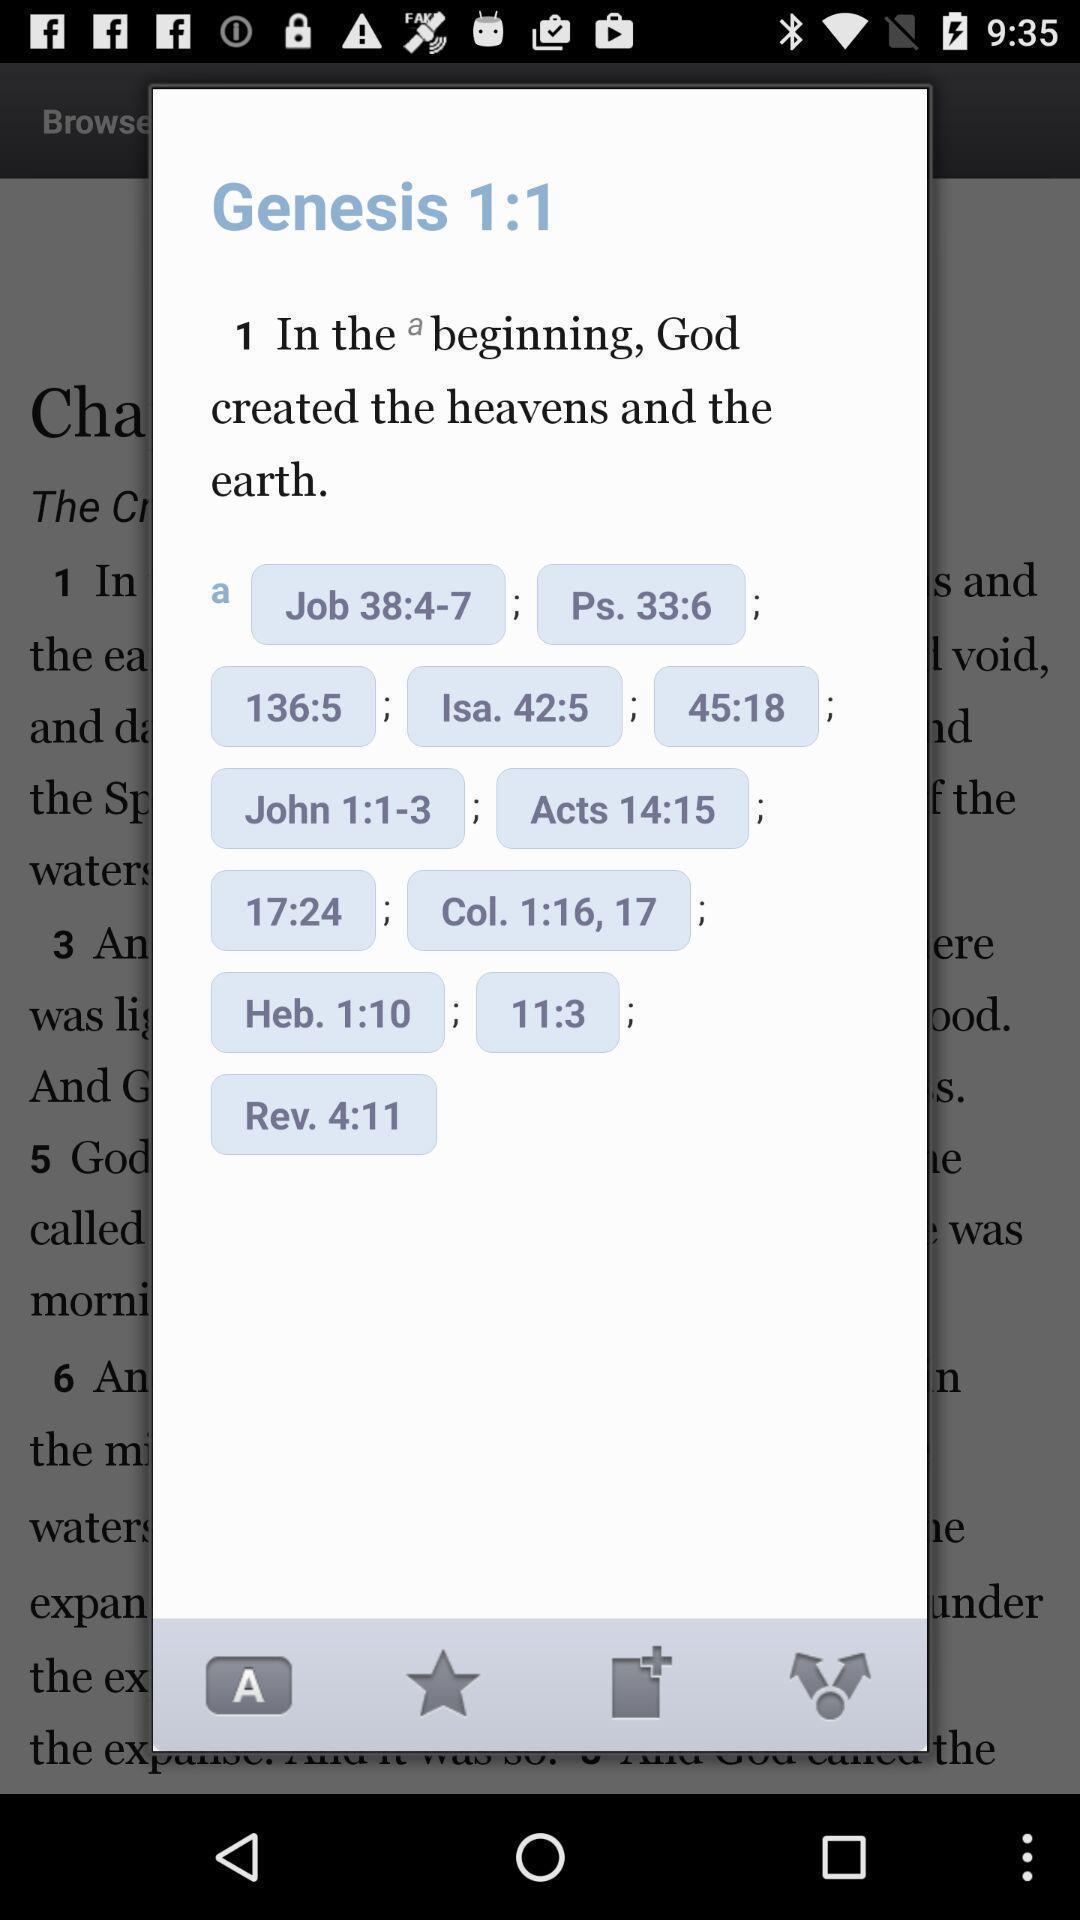Explain the elements present in this screenshot. Pop-up showing the multiple options. 